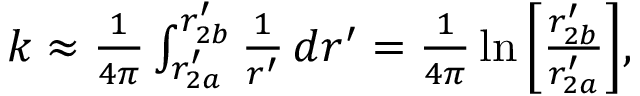Convert formula to latex. <formula><loc_0><loc_0><loc_500><loc_500>\begin{array} { r } { k \approx \frac { 1 } { 4 \pi } \int _ { r _ { 2 a } ^ { \prime } } ^ { r _ { 2 b } ^ { \prime } } \frac { 1 } { r ^ { \prime } } \, d r ^ { \prime } = \frac { 1 } { 4 \pi } \ln { \left [ \frac { r _ { 2 b } ^ { \prime } } { r _ { 2 a } ^ { \prime } } \right ] } , } \end{array}</formula> 